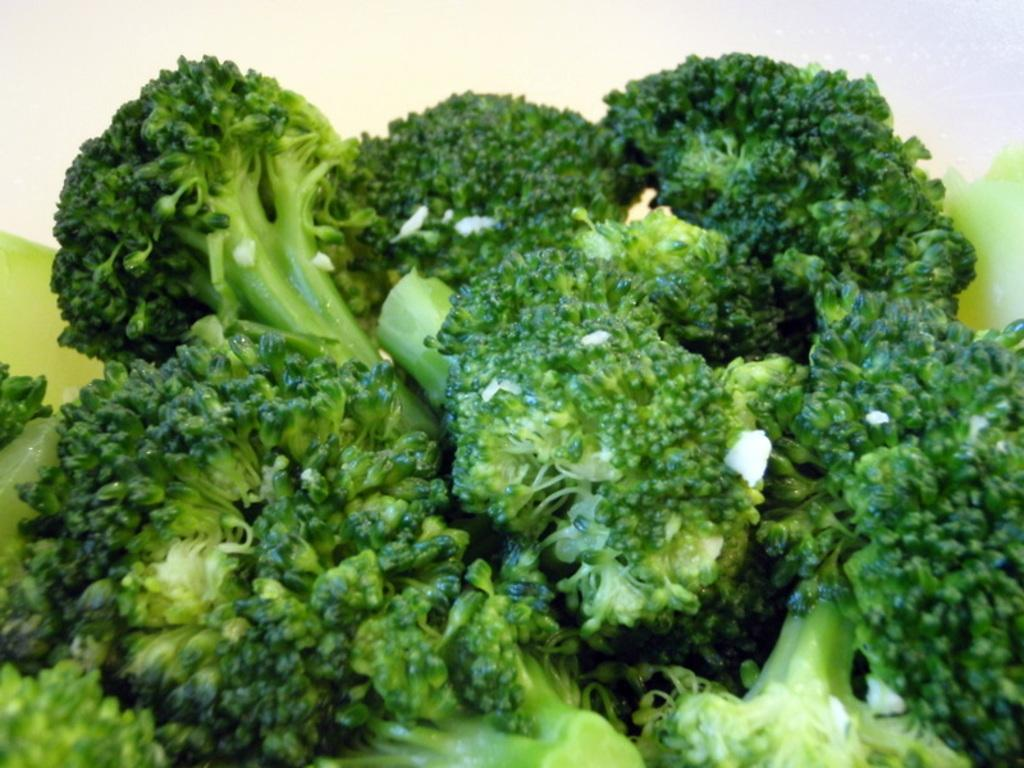What type of food is arranged in the image? There are broccoli pieces arranged in the image. What color is the background of the image? The background of the image is white in color. How many ants can be seen crawling on the broccoli pieces in the image? There are no ants present in the image. 